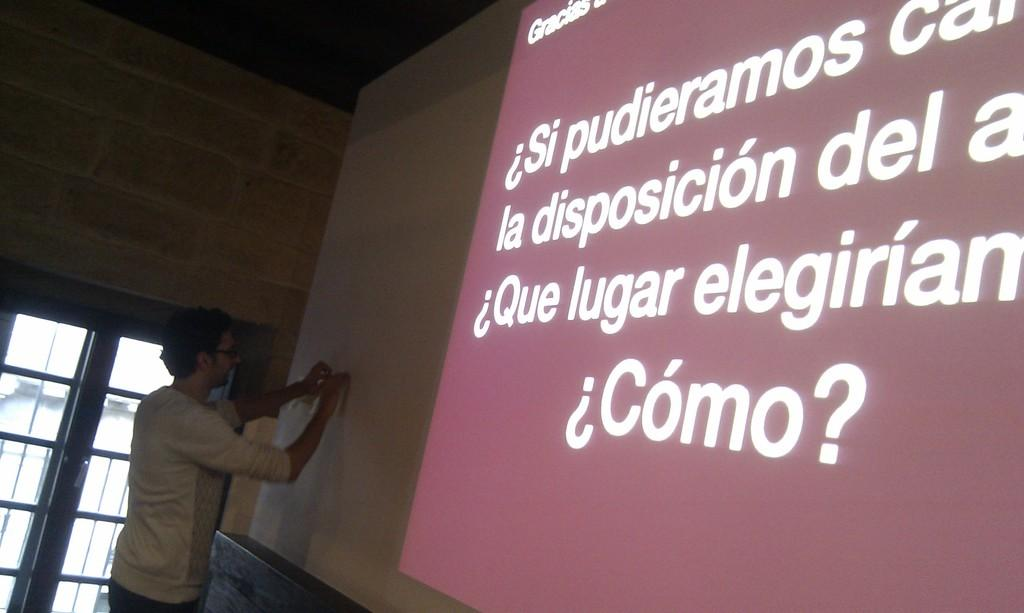Who is present in the image? There is a man in the image. What can be seen on the screen in the image? The facts do not specify what is on the screen, so we cannot answer this question definitively. What is visible in the background of the image? There is a wall and a door in the background of the image. How many trains can be seen passing by in the image? There are no trains present in the image. What type of pen is the visitor using to write in the image? There is no visitor or pen present in the image. 